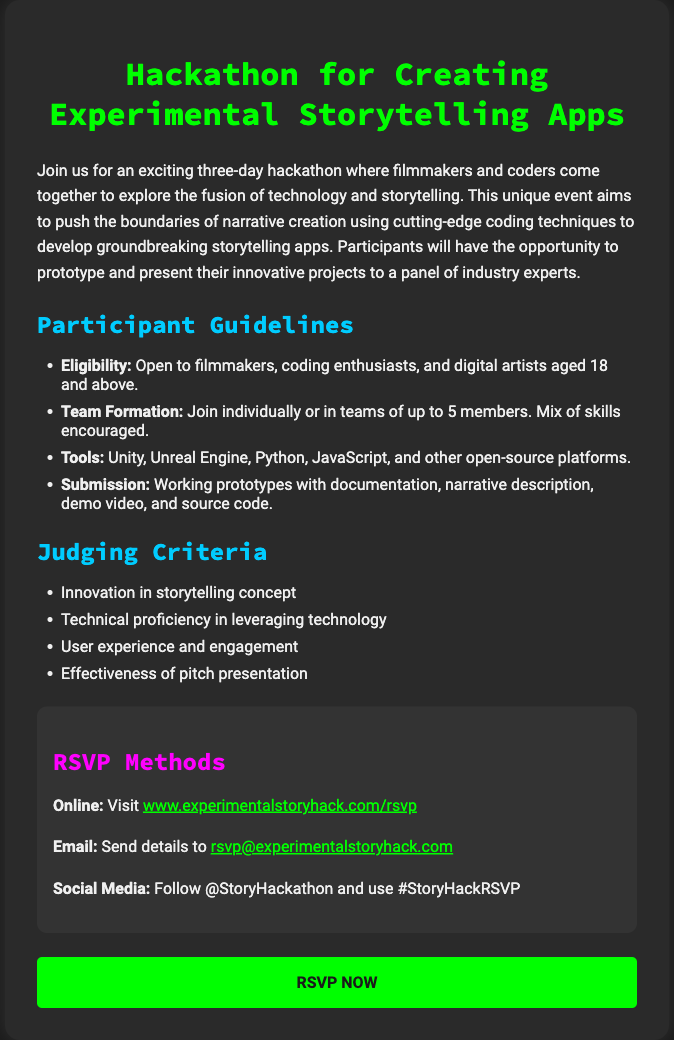What is the duration of the hackathon? The document states that the hackathon lasts for three days.
Answer: three days Who are the eligible participants? Eligibility criteria mentioned in the document states it is open to filmmakers, coding enthusiasts, and digital artists aged 18 and above.
Answer: filmmakers, coding enthusiasts, and digital artists aged 18 and above What tools can be used during the hackathon? The document lists Unity, Unreal Engine, Python, JavaScript, and other open-source platforms as allowed tools.
Answer: Unity, Unreal Engine, Python, JavaScript, and other open-source platforms What is one criterion for judging? The document specifies "Innovation in storytelling concept" as one of the judging criteria.
Answer: Innovation in storytelling concept How can participants RSVP online? The RSVP methods section provides a link to visit for online RSVP.
Answer: www.experimentalstoryhack.com/rsvp What is the maximum team size allowed? The document states that teams can have up to 5 members.
Answer: 5 members Which social media handle should participants follow? The document advises following @StoryHackathon on social media.
Answer: @StoryHackathon 